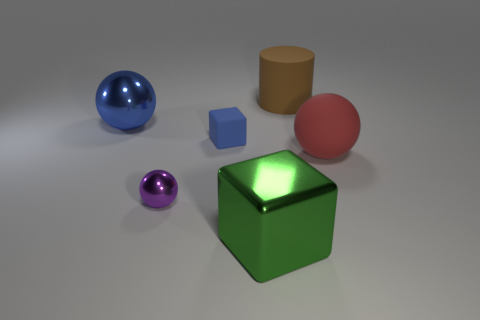Is the number of brown objects in front of the tiny rubber object the same as the number of tiny blue objects?
Your answer should be compact. No. What number of brown cylinders have the same material as the blue ball?
Ensure brevity in your answer.  0. What is the color of the other large thing that is made of the same material as the red object?
Make the answer very short. Brown. Do the purple metallic thing and the blue object that is left of the tiny rubber thing have the same size?
Provide a succinct answer. No. There is a large green thing; what shape is it?
Your response must be concise. Cube. What number of tiny rubber things are the same color as the tiny sphere?
Give a very brief answer. 0. There is another metal thing that is the same shape as the tiny blue object; what color is it?
Make the answer very short. Green. How many red balls are left of the metallic object that is on the right side of the purple shiny ball?
Ensure brevity in your answer.  0. How many cubes are tiny blue matte objects or small yellow shiny objects?
Provide a short and direct response. 1. Is there a large matte ball?
Make the answer very short. Yes. 